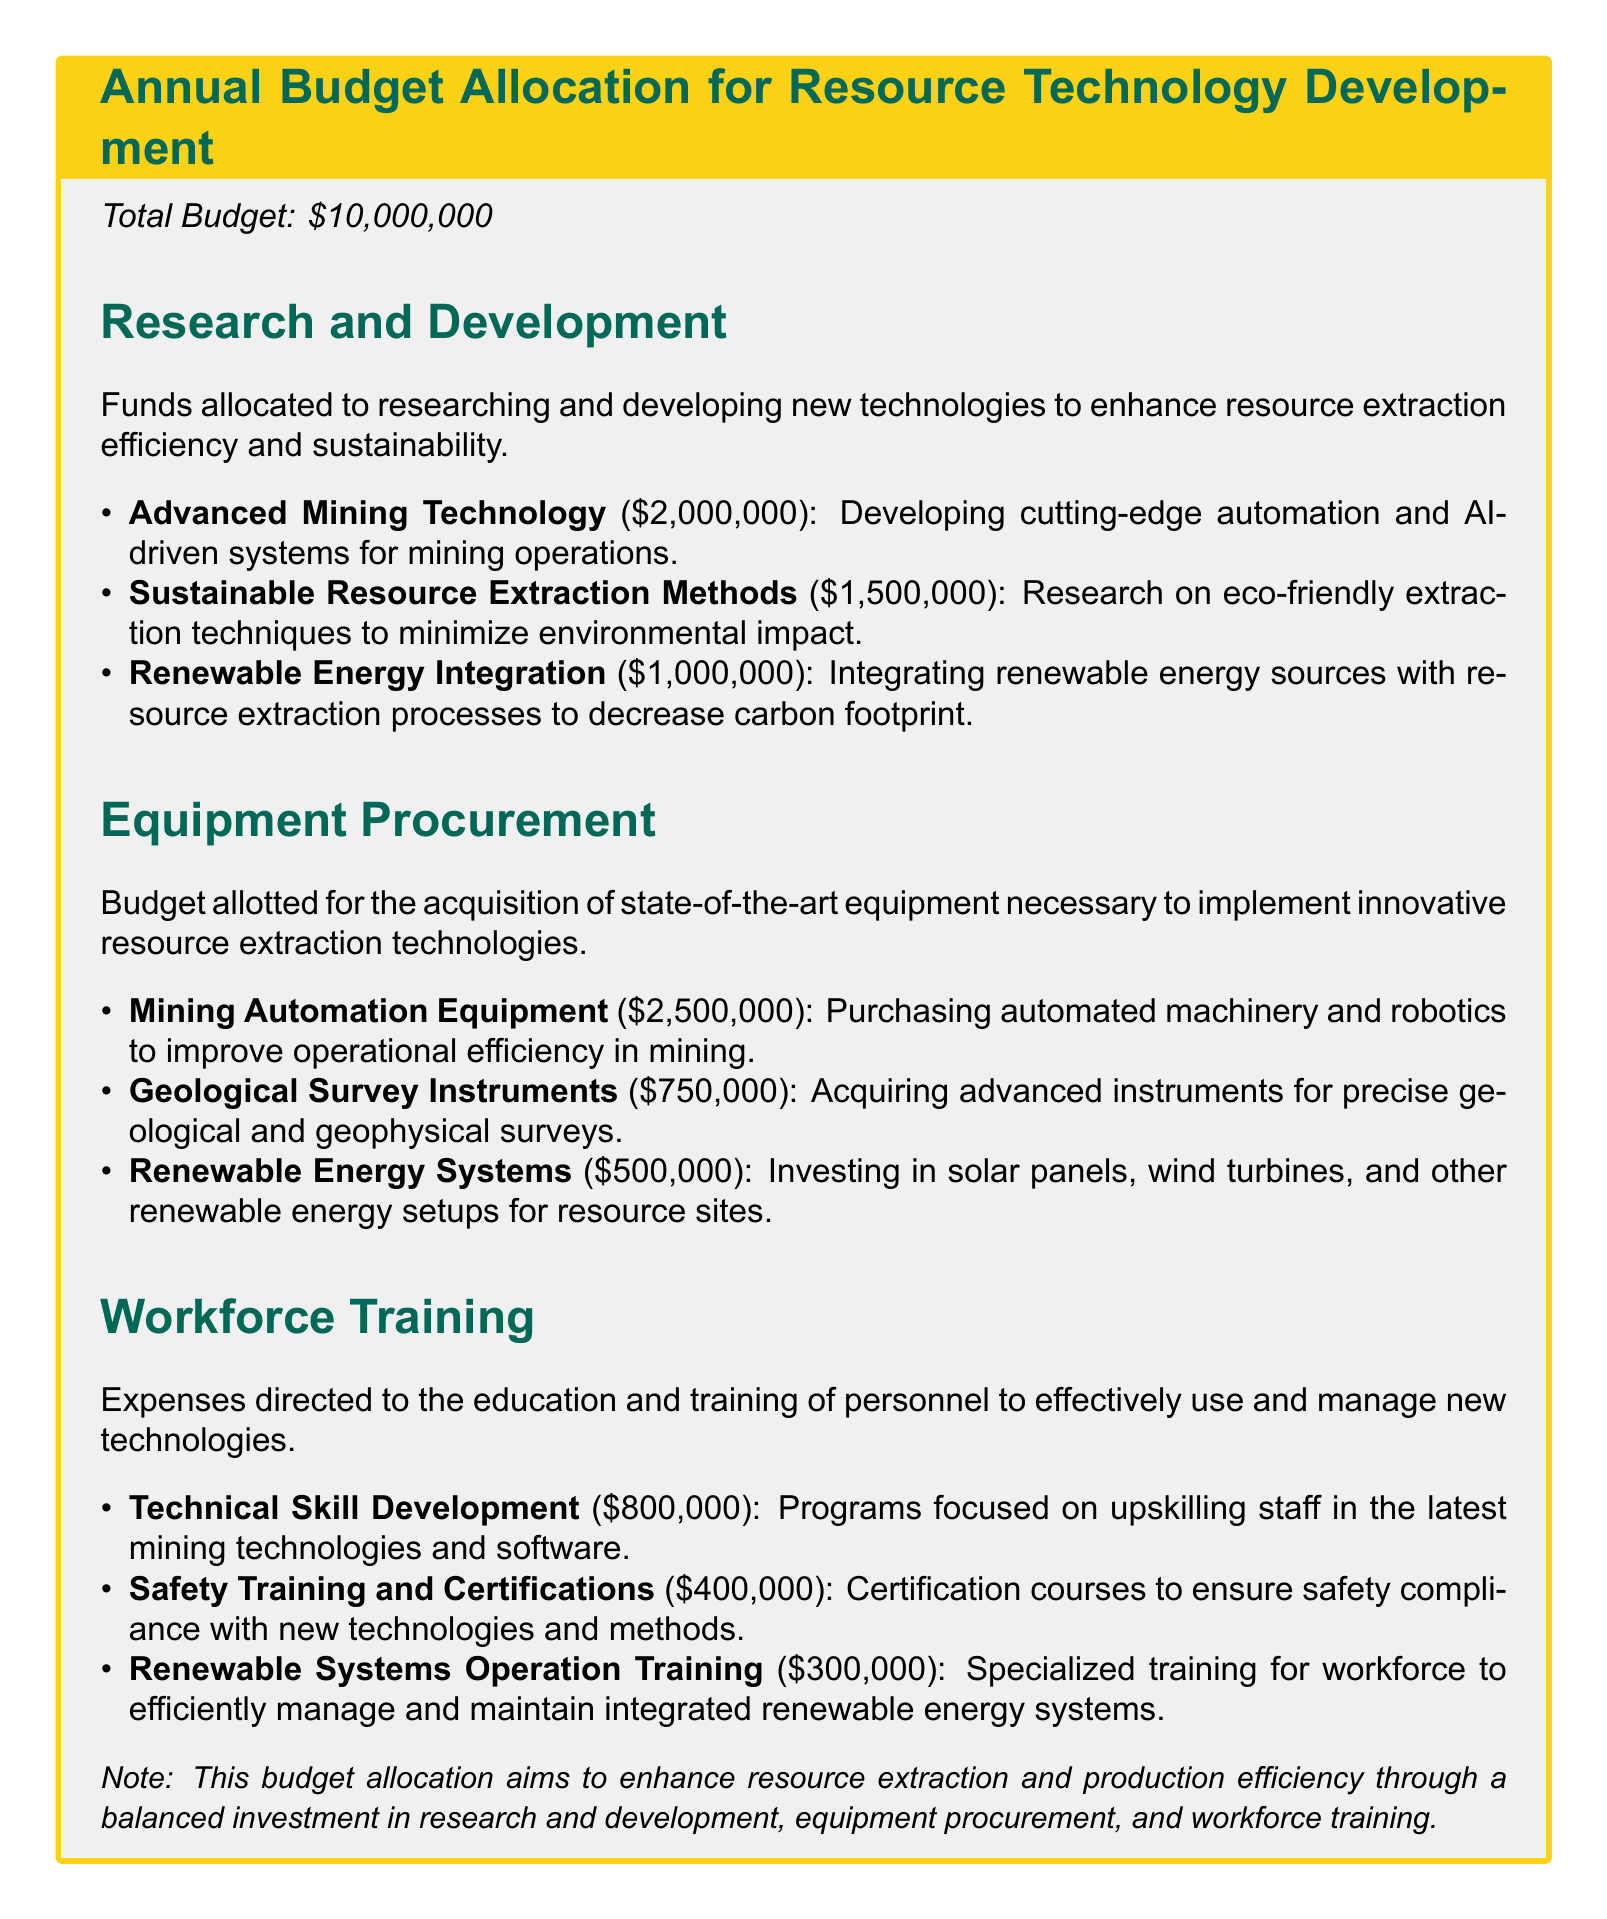What is the total budget? The total budget is explicitly stated in the document.
Answer: $10,000,000 How much is allocated for Advanced Mining Technology? The amount for Advanced Mining Technology is listed under the Research and Development section.
Answer: $2,000,000 What percentage of the total budget is allocated to Equipment Procurement? This requires calculating the total for Equipment Procurement and comparing it to the total budget. Total for Equipment Procurement is $3,750,000, which is 37.5% of the total budget.
Answer: 37.5% How many projects are listed under Workforce Training? The number of projects in the Workforce Training section is counted from the list.
Answer: 3 What is the main focus of Sustainable Resource Extraction Methods? The focus is described in the context of enhancing eco-friendliness in extraction techniques.
Answer: Eco-friendly extraction What is the budget for Safety Training and Certifications? The specific budget item for Safety Training and Certifications is mentioned directly.
Answer: $400,000 What type of systems are included in the Renewable Energy Systems procurement? This question seeks specific technology types mentioned in the Equipment Procurement section.
Answer: Solar panels, wind turbines What is the key goal of this budget allocation? The primary aim is summarized in the note at the bottom of the document.
Answer: Enhance resource extraction and production efficiency What is the total funding for Research and Development? The total funding for all projects listed under Research and Development needs to be calculated.
Answer: $4,500,000 